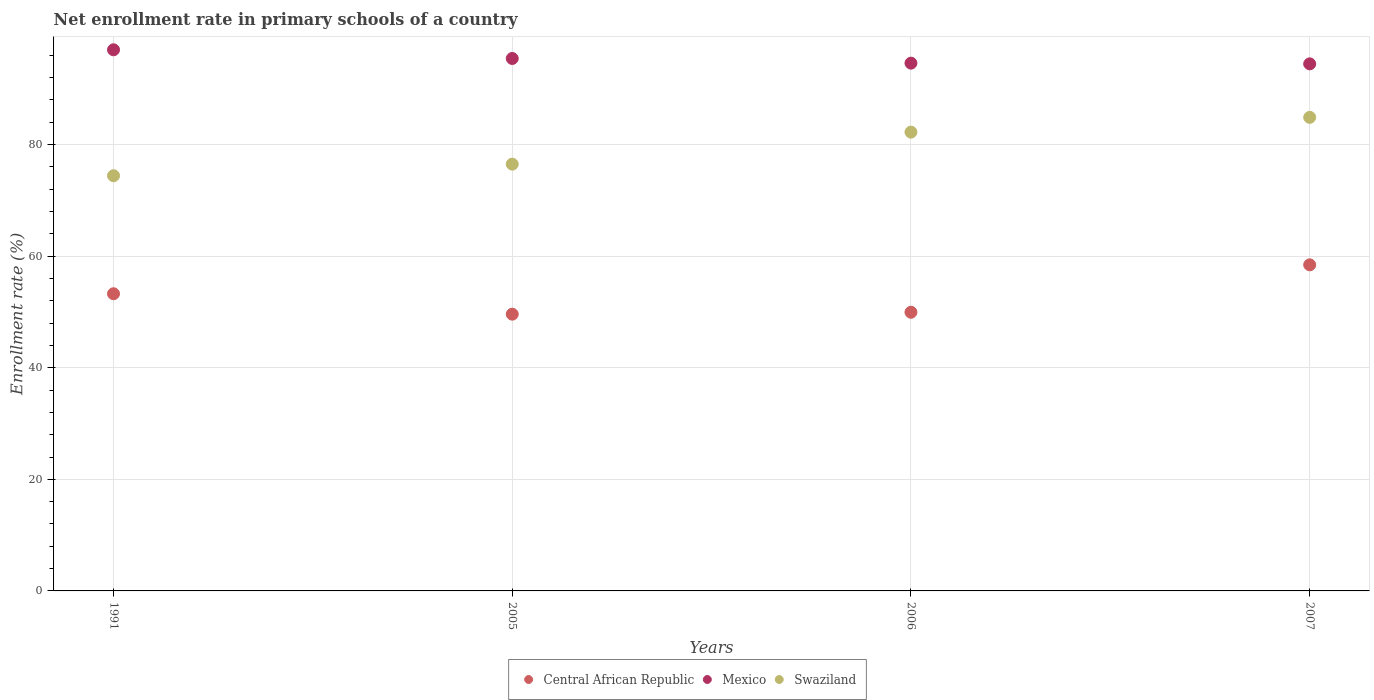How many different coloured dotlines are there?
Your response must be concise. 3. Is the number of dotlines equal to the number of legend labels?
Give a very brief answer. Yes. What is the enrollment rate in primary schools in Mexico in 1991?
Offer a very short reply. 96.98. Across all years, what is the maximum enrollment rate in primary schools in Mexico?
Offer a very short reply. 96.98. Across all years, what is the minimum enrollment rate in primary schools in Mexico?
Provide a succinct answer. 94.46. In which year was the enrollment rate in primary schools in Central African Republic maximum?
Your response must be concise. 2007. In which year was the enrollment rate in primary schools in Central African Republic minimum?
Offer a terse response. 2005. What is the total enrollment rate in primary schools in Swaziland in the graph?
Keep it short and to the point. 317.99. What is the difference between the enrollment rate in primary schools in Central African Republic in 1991 and that in 2005?
Ensure brevity in your answer.  3.66. What is the difference between the enrollment rate in primary schools in Central African Republic in 2006 and the enrollment rate in primary schools in Mexico in 1991?
Offer a very short reply. -47.04. What is the average enrollment rate in primary schools in Swaziland per year?
Offer a very short reply. 79.5. In the year 2006, what is the difference between the enrollment rate in primary schools in Mexico and enrollment rate in primary schools in Central African Republic?
Offer a very short reply. 44.64. In how many years, is the enrollment rate in primary schools in Mexico greater than 36 %?
Your answer should be very brief. 4. What is the ratio of the enrollment rate in primary schools in Mexico in 2006 to that in 2007?
Offer a very short reply. 1. Is the difference between the enrollment rate in primary schools in Mexico in 2005 and 2007 greater than the difference between the enrollment rate in primary schools in Central African Republic in 2005 and 2007?
Your response must be concise. Yes. What is the difference between the highest and the second highest enrollment rate in primary schools in Mexico?
Your answer should be very brief. 1.56. What is the difference between the highest and the lowest enrollment rate in primary schools in Mexico?
Offer a terse response. 2.52. In how many years, is the enrollment rate in primary schools in Swaziland greater than the average enrollment rate in primary schools in Swaziland taken over all years?
Keep it short and to the point. 2. Is the sum of the enrollment rate in primary schools in Central African Republic in 1991 and 2005 greater than the maximum enrollment rate in primary schools in Swaziland across all years?
Make the answer very short. Yes. Does the enrollment rate in primary schools in Central African Republic monotonically increase over the years?
Make the answer very short. No. Is the enrollment rate in primary schools in Swaziland strictly greater than the enrollment rate in primary schools in Central African Republic over the years?
Your answer should be compact. Yes. How many years are there in the graph?
Your answer should be compact. 4. What is the difference between two consecutive major ticks on the Y-axis?
Make the answer very short. 20. Does the graph contain any zero values?
Make the answer very short. No. Where does the legend appear in the graph?
Keep it short and to the point. Bottom center. How are the legend labels stacked?
Give a very brief answer. Horizontal. What is the title of the graph?
Your response must be concise. Net enrollment rate in primary schools of a country. What is the label or title of the Y-axis?
Provide a succinct answer. Enrollment rate (%). What is the Enrollment rate (%) in Central African Republic in 1991?
Make the answer very short. 53.26. What is the Enrollment rate (%) of Mexico in 1991?
Your response must be concise. 96.98. What is the Enrollment rate (%) of Swaziland in 1991?
Ensure brevity in your answer.  74.41. What is the Enrollment rate (%) in Central African Republic in 2005?
Keep it short and to the point. 49.6. What is the Enrollment rate (%) in Mexico in 2005?
Make the answer very short. 95.42. What is the Enrollment rate (%) in Swaziland in 2005?
Give a very brief answer. 76.49. What is the Enrollment rate (%) in Central African Republic in 2006?
Keep it short and to the point. 49.94. What is the Enrollment rate (%) of Mexico in 2006?
Provide a short and direct response. 94.59. What is the Enrollment rate (%) in Swaziland in 2006?
Your answer should be compact. 82.22. What is the Enrollment rate (%) in Central African Republic in 2007?
Make the answer very short. 58.44. What is the Enrollment rate (%) of Mexico in 2007?
Offer a terse response. 94.46. What is the Enrollment rate (%) of Swaziland in 2007?
Offer a very short reply. 84.87. Across all years, what is the maximum Enrollment rate (%) of Central African Republic?
Offer a very short reply. 58.44. Across all years, what is the maximum Enrollment rate (%) in Mexico?
Provide a short and direct response. 96.98. Across all years, what is the maximum Enrollment rate (%) of Swaziland?
Your answer should be compact. 84.87. Across all years, what is the minimum Enrollment rate (%) of Central African Republic?
Offer a very short reply. 49.6. Across all years, what is the minimum Enrollment rate (%) of Mexico?
Provide a succinct answer. 94.46. Across all years, what is the minimum Enrollment rate (%) in Swaziland?
Ensure brevity in your answer.  74.41. What is the total Enrollment rate (%) of Central African Republic in the graph?
Offer a very short reply. 211.24. What is the total Enrollment rate (%) in Mexico in the graph?
Offer a very short reply. 381.45. What is the total Enrollment rate (%) of Swaziland in the graph?
Your response must be concise. 317.99. What is the difference between the Enrollment rate (%) of Central African Republic in 1991 and that in 2005?
Provide a succinct answer. 3.66. What is the difference between the Enrollment rate (%) in Mexico in 1991 and that in 2005?
Offer a very short reply. 1.56. What is the difference between the Enrollment rate (%) of Swaziland in 1991 and that in 2005?
Your answer should be compact. -2.08. What is the difference between the Enrollment rate (%) in Central African Republic in 1991 and that in 2006?
Offer a very short reply. 3.31. What is the difference between the Enrollment rate (%) in Mexico in 1991 and that in 2006?
Offer a terse response. 2.39. What is the difference between the Enrollment rate (%) in Swaziland in 1991 and that in 2006?
Offer a terse response. -7.81. What is the difference between the Enrollment rate (%) of Central African Republic in 1991 and that in 2007?
Offer a terse response. -5.18. What is the difference between the Enrollment rate (%) in Mexico in 1991 and that in 2007?
Make the answer very short. 2.52. What is the difference between the Enrollment rate (%) of Swaziland in 1991 and that in 2007?
Make the answer very short. -10.46. What is the difference between the Enrollment rate (%) in Central African Republic in 2005 and that in 2006?
Give a very brief answer. -0.34. What is the difference between the Enrollment rate (%) of Mexico in 2005 and that in 2006?
Give a very brief answer. 0.84. What is the difference between the Enrollment rate (%) in Swaziland in 2005 and that in 2006?
Provide a succinct answer. -5.74. What is the difference between the Enrollment rate (%) in Central African Republic in 2005 and that in 2007?
Provide a succinct answer. -8.84. What is the difference between the Enrollment rate (%) of Mexico in 2005 and that in 2007?
Provide a short and direct response. 0.96. What is the difference between the Enrollment rate (%) in Swaziland in 2005 and that in 2007?
Make the answer very short. -8.38. What is the difference between the Enrollment rate (%) in Central African Republic in 2006 and that in 2007?
Your response must be concise. -8.5. What is the difference between the Enrollment rate (%) of Mexico in 2006 and that in 2007?
Offer a very short reply. 0.13. What is the difference between the Enrollment rate (%) in Swaziland in 2006 and that in 2007?
Provide a succinct answer. -2.65. What is the difference between the Enrollment rate (%) in Central African Republic in 1991 and the Enrollment rate (%) in Mexico in 2005?
Provide a short and direct response. -42.16. What is the difference between the Enrollment rate (%) of Central African Republic in 1991 and the Enrollment rate (%) of Swaziland in 2005?
Keep it short and to the point. -23.23. What is the difference between the Enrollment rate (%) in Mexico in 1991 and the Enrollment rate (%) in Swaziland in 2005?
Ensure brevity in your answer.  20.49. What is the difference between the Enrollment rate (%) of Central African Republic in 1991 and the Enrollment rate (%) of Mexico in 2006?
Your answer should be compact. -41.33. What is the difference between the Enrollment rate (%) in Central African Republic in 1991 and the Enrollment rate (%) in Swaziland in 2006?
Give a very brief answer. -28.97. What is the difference between the Enrollment rate (%) in Mexico in 1991 and the Enrollment rate (%) in Swaziland in 2006?
Keep it short and to the point. 14.76. What is the difference between the Enrollment rate (%) in Central African Republic in 1991 and the Enrollment rate (%) in Mexico in 2007?
Keep it short and to the point. -41.2. What is the difference between the Enrollment rate (%) of Central African Republic in 1991 and the Enrollment rate (%) of Swaziland in 2007?
Offer a very short reply. -31.61. What is the difference between the Enrollment rate (%) of Mexico in 1991 and the Enrollment rate (%) of Swaziland in 2007?
Offer a terse response. 12.11. What is the difference between the Enrollment rate (%) in Central African Republic in 2005 and the Enrollment rate (%) in Mexico in 2006?
Offer a very short reply. -44.99. What is the difference between the Enrollment rate (%) in Central African Republic in 2005 and the Enrollment rate (%) in Swaziland in 2006?
Offer a terse response. -32.63. What is the difference between the Enrollment rate (%) in Mexico in 2005 and the Enrollment rate (%) in Swaziland in 2006?
Give a very brief answer. 13.2. What is the difference between the Enrollment rate (%) of Central African Republic in 2005 and the Enrollment rate (%) of Mexico in 2007?
Give a very brief answer. -44.86. What is the difference between the Enrollment rate (%) of Central African Republic in 2005 and the Enrollment rate (%) of Swaziland in 2007?
Ensure brevity in your answer.  -35.27. What is the difference between the Enrollment rate (%) in Mexico in 2005 and the Enrollment rate (%) in Swaziland in 2007?
Provide a short and direct response. 10.55. What is the difference between the Enrollment rate (%) of Central African Republic in 2006 and the Enrollment rate (%) of Mexico in 2007?
Your answer should be very brief. -44.52. What is the difference between the Enrollment rate (%) of Central African Republic in 2006 and the Enrollment rate (%) of Swaziland in 2007?
Your response must be concise. -34.93. What is the difference between the Enrollment rate (%) in Mexico in 2006 and the Enrollment rate (%) in Swaziland in 2007?
Your response must be concise. 9.72. What is the average Enrollment rate (%) in Central African Republic per year?
Offer a terse response. 52.81. What is the average Enrollment rate (%) of Mexico per year?
Give a very brief answer. 95.36. What is the average Enrollment rate (%) of Swaziland per year?
Your response must be concise. 79.5. In the year 1991, what is the difference between the Enrollment rate (%) of Central African Republic and Enrollment rate (%) of Mexico?
Offer a very short reply. -43.72. In the year 1991, what is the difference between the Enrollment rate (%) in Central African Republic and Enrollment rate (%) in Swaziland?
Your answer should be compact. -21.15. In the year 1991, what is the difference between the Enrollment rate (%) in Mexico and Enrollment rate (%) in Swaziland?
Provide a succinct answer. 22.57. In the year 2005, what is the difference between the Enrollment rate (%) of Central African Republic and Enrollment rate (%) of Mexico?
Your answer should be very brief. -45.82. In the year 2005, what is the difference between the Enrollment rate (%) of Central African Republic and Enrollment rate (%) of Swaziland?
Keep it short and to the point. -26.89. In the year 2005, what is the difference between the Enrollment rate (%) in Mexico and Enrollment rate (%) in Swaziland?
Keep it short and to the point. 18.93. In the year 2006, what is the difference between the Enrollment rate (%) of Central African Republic and Enrollment rate (%) of Mexico?
Offer a very short reply. -44.64. In the year 2006, what is the difference between the Enrollment rate (%) of Central African Republic and Enrollment rate (%) of Swaziland?
Your answer should be compact. -32.28. In the year 2006, what is the difference between the Enrollment rate (%) of Mexico and Enrollment rate (%) of Swaziland?
Provide a short and direct response. 12.36. In the year 2007, what is the difference between the Enrollment rate (%) of Central African Republic and Enrollment rate (%) of Mexico?
Ensure brevity in your answer.  -36.02. In the year 2007, what is the difference between the Enrollment rate (%) of Central African Republic and Enrollment rate (%) of Swaziland?
Your response must be concise. -26.43. In the year 2007, what is the difference between the Enrollment rate (%) in Mexico and Enrollment rate (%) in Swaziland?
Provide a succinct answer. 9.59. What is the ratio of the Enrollment rate (%) of Central African Republic in 1991 to that in 2005?
Provide a succinct answer. 1.07. What is the ratio of the Enrollment rate (%) of Mexico in 1991 to that in 2005?
Give a very brief answer. 1.02. What is the ratio of the Enrollment rate (%) in Swaziland in 1991 to that in 2005?
Keep it short and to the point. 0.97. What is the ratio of the Enrollment rate (%) of Central African Republic in 1991 to that in 2006?
Provide a short and direct response. 1.07. What is the ratio of the Enrollment rate (%) in Mexico in 1991 to that in 2006?
Provide a succinct answer. 1.03. What is the ratio of the Enrollment rate (%) of Swaziland in 1991 to that in 2006?
Make the answer very short. 0.91. What is the ratio of the Enrollment rate (%) in Central African Republic in 1991 to that in 2007?
Make the answer very short. 0.91. What is the ratio of the Enrollment rate (%) in Mexico in 1991 to that in 2007?
Offer a very short reply. 1.03. What is the ratio of the Enrollment rate (%) of Swaziland in 1991 to that in 2007?
Your answer should be compact. 0.88. What is the ratio of the Enrollment rate (%) of Mexico in 2005 to that in 2006?
Your answer should be compact. 1.01. What is the ratio of the Enrollment rate (%) in Swaziland in 2005 to that in 2006?
Make the answer very short. 0.93. What is the ratio of the Enrollment rate (%) in Central African Republic in 2005 to that in 2007?
Your answer should be compact. 0.85. What is the ratio of the Enrollment rate (%) of Mexico in 2005 to that in 2007?
Your response must be concise. 1.01. What is the ratio of the Enrollment rate (%) in Swaziland in 2005 to that in 2007?
Your answer should be compact. 0.9. What is the ratio of the Enrollment rate (%) of Central African Republic in 2006 to that in 2007?
Ensure brevity in your answer.  0.85. What is the ratio of the Enrollment rate (%) in Swaziland in 2006 to that in 2007?
Provide a short and direct response. 0.97. What is the difference between the highest and the second highest Enrollment rate (%) in Central African Republic?
Keep it short and to the point. 5.18. What is the difference between the highest and the second highest Enrollment rate (%) of Mexico?
Provide a succinct answer. 1.56. What is the difference between the highest and the second highest Enrollment rate (%) in Swaziland?
Your response must be concise. 2.65. What is the difference between the highest and the lowest Enrollment rate (%) in Central African Republic?
Keep it short and to the point. 8.84. What is the difference between the highest and the lowest Enrollment rate (%) of Mexico?
Provide a short and direct response. 2.52. What is the difference between the highest and the lowest Enrollment rate (%) of Swaziland?
Provide a succinct answer. 10.46. 